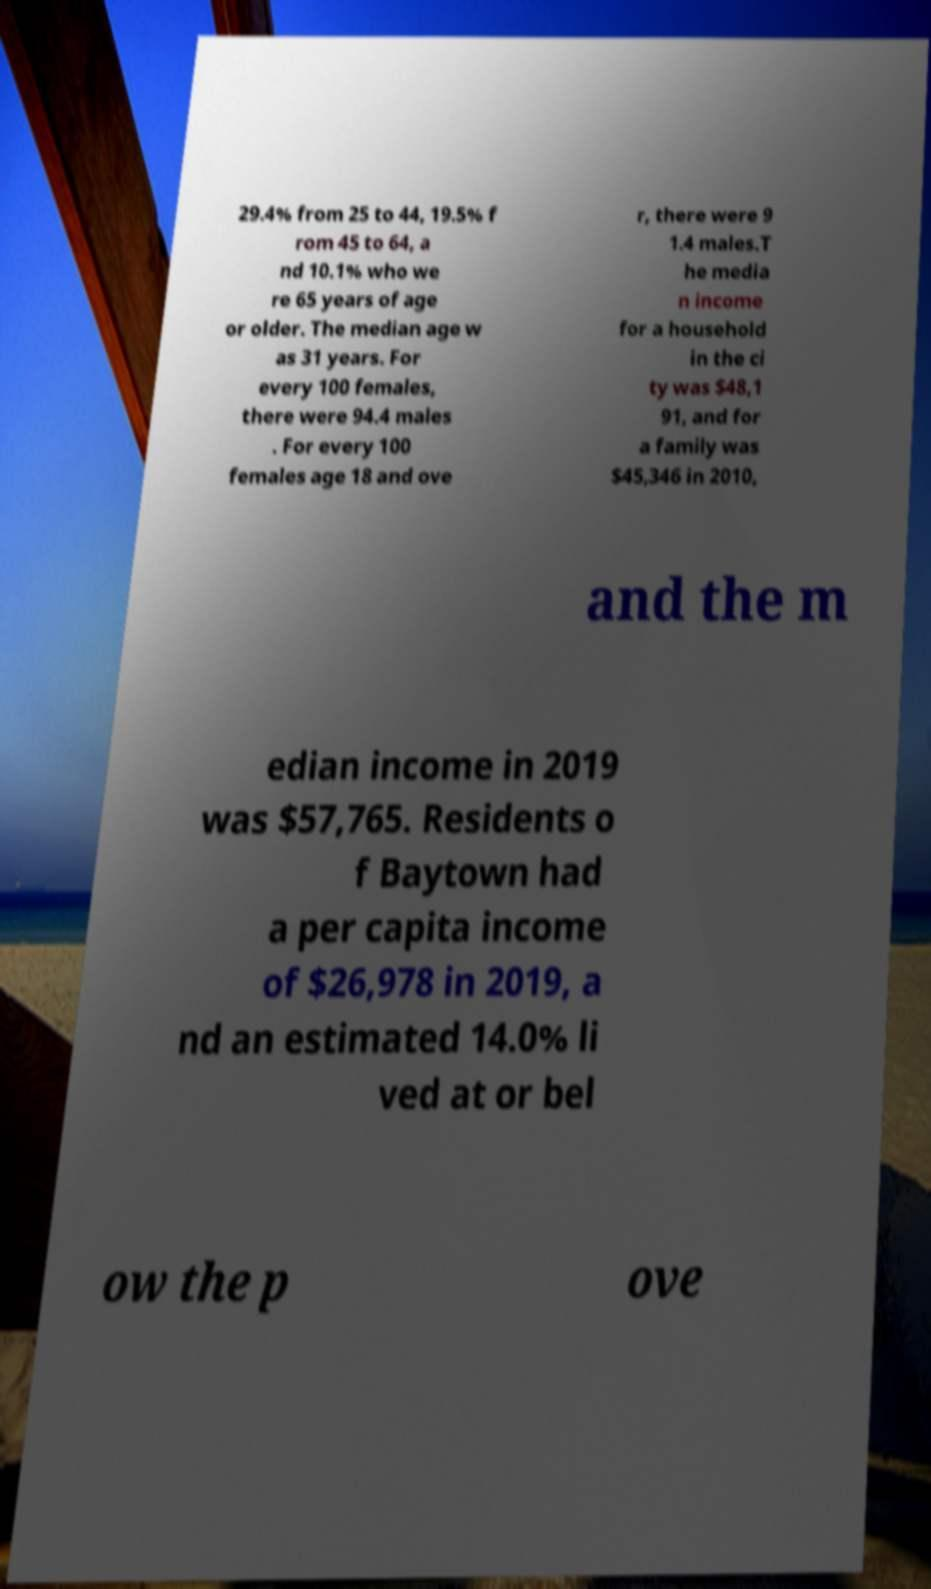I need the written content from this picture converted into text. Can you do that? 29.4% from 25 to 44, 19.5% f rom 45 to 64, a nd 10.1% who we re 65 years of age or older. The median age w as 31 years. For every 100 females, there were 94.4 males . For every 100 females age 18 and ove r, there were 9 1.4 males.T he media n income for a household in the ci ty was $48,1 91, and for a family was $45,346 in 2010, and the m edian income in 2019 was $57,765. Residents o f Baytown had a per capita income of $26,978 in 2019, a nd an estimated 14.0% li ved at or bel ow the p ove 